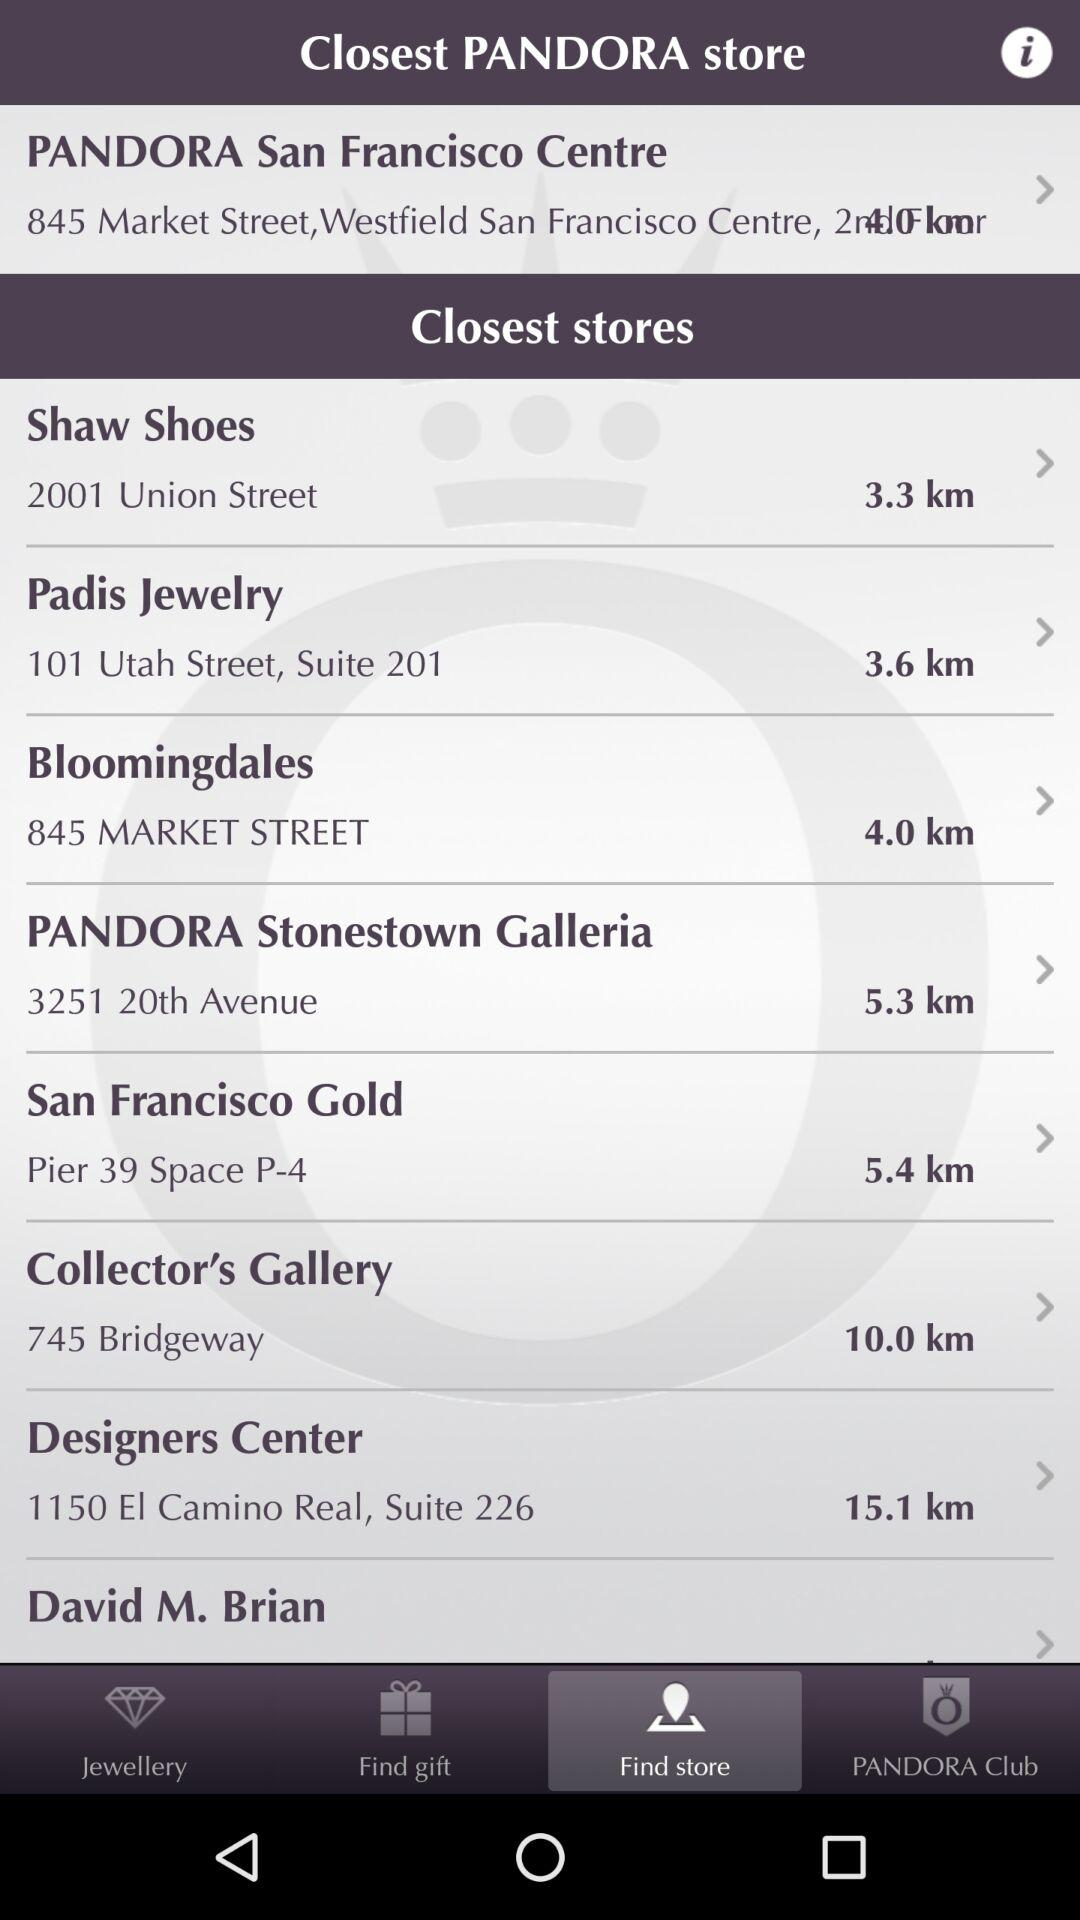Which tab has been selected? The tab that has been selected is "Find store". 